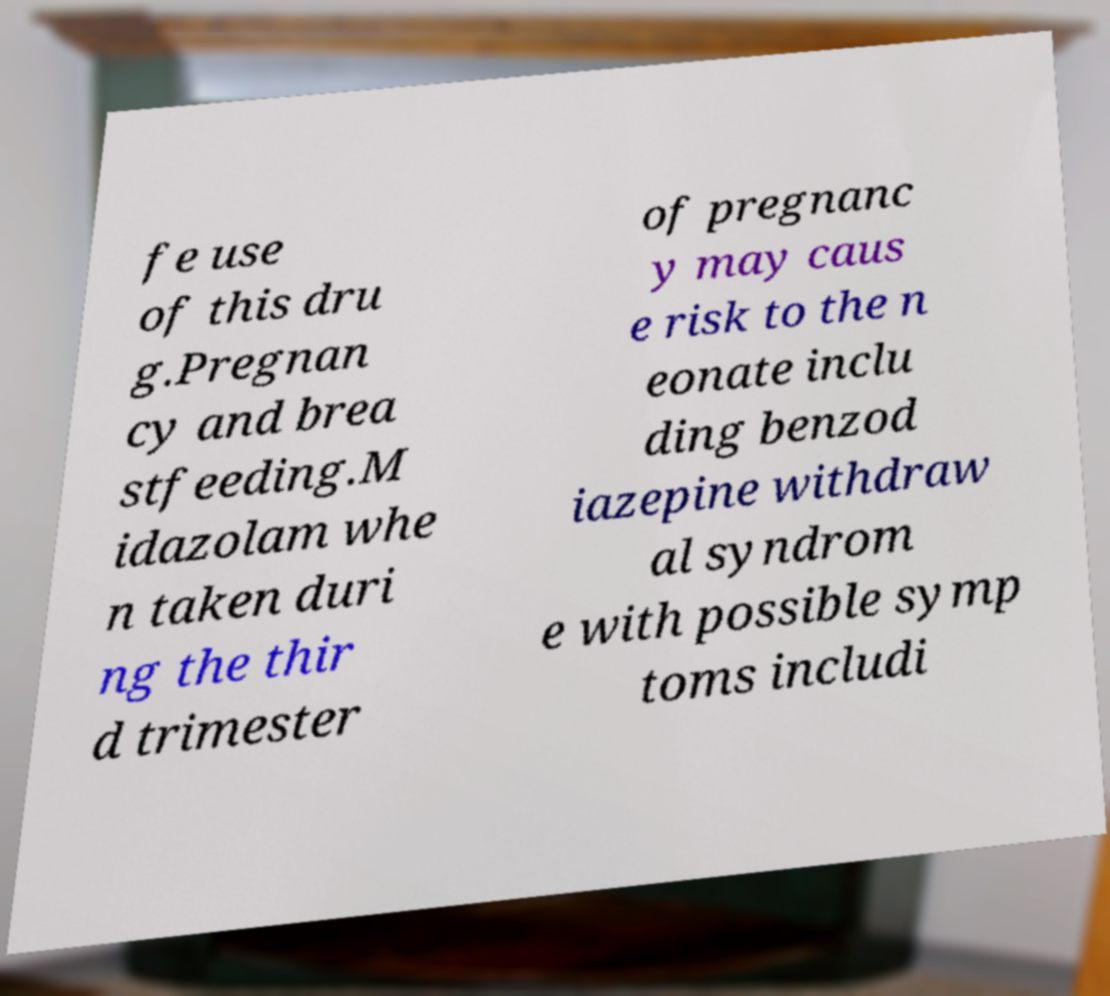Can you accurately transcribe the text from the provided image for me? fe use of this dru g.Pregnan cy and brea stfeeding.M idazolam whe n taken duri ng the thir d trimester of pregnanc y may caus e risk to the n eonate inclu ding benzod iazepine withdraw al syndrom e with possible symp toms includi 